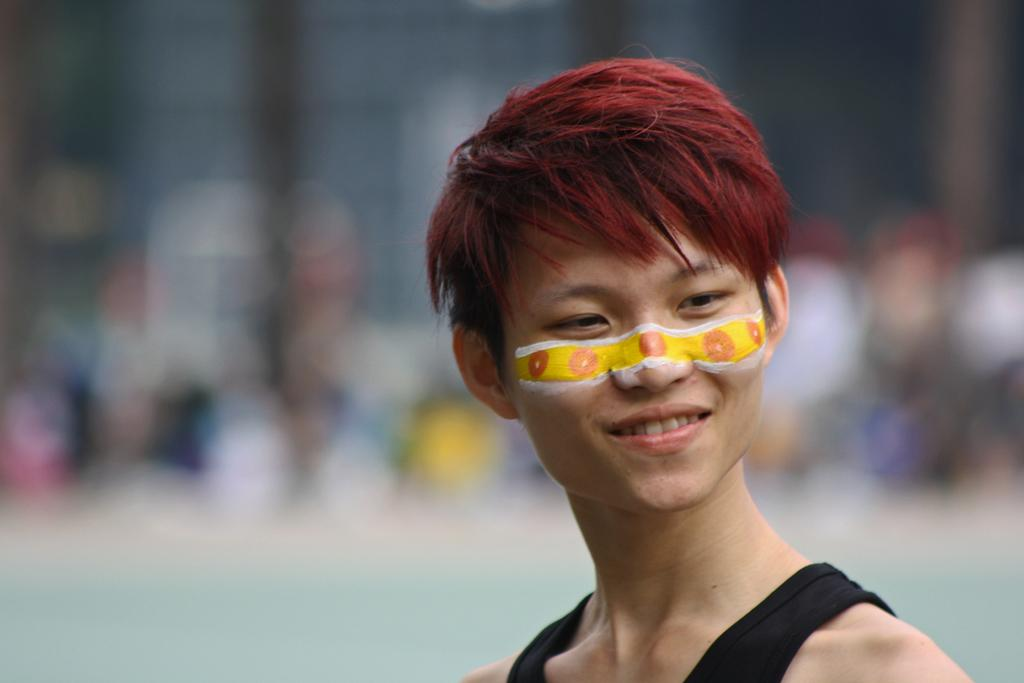What is the main subject in the image? There is a person standing in the image. How is the person's face painted? The person's face is painted with white, red, and yellow colors. What type of mark can be heard coming from the person's voice in the image? There is no sound or voice present in the image, so it is not possible to determine what type of mark might be heard. 